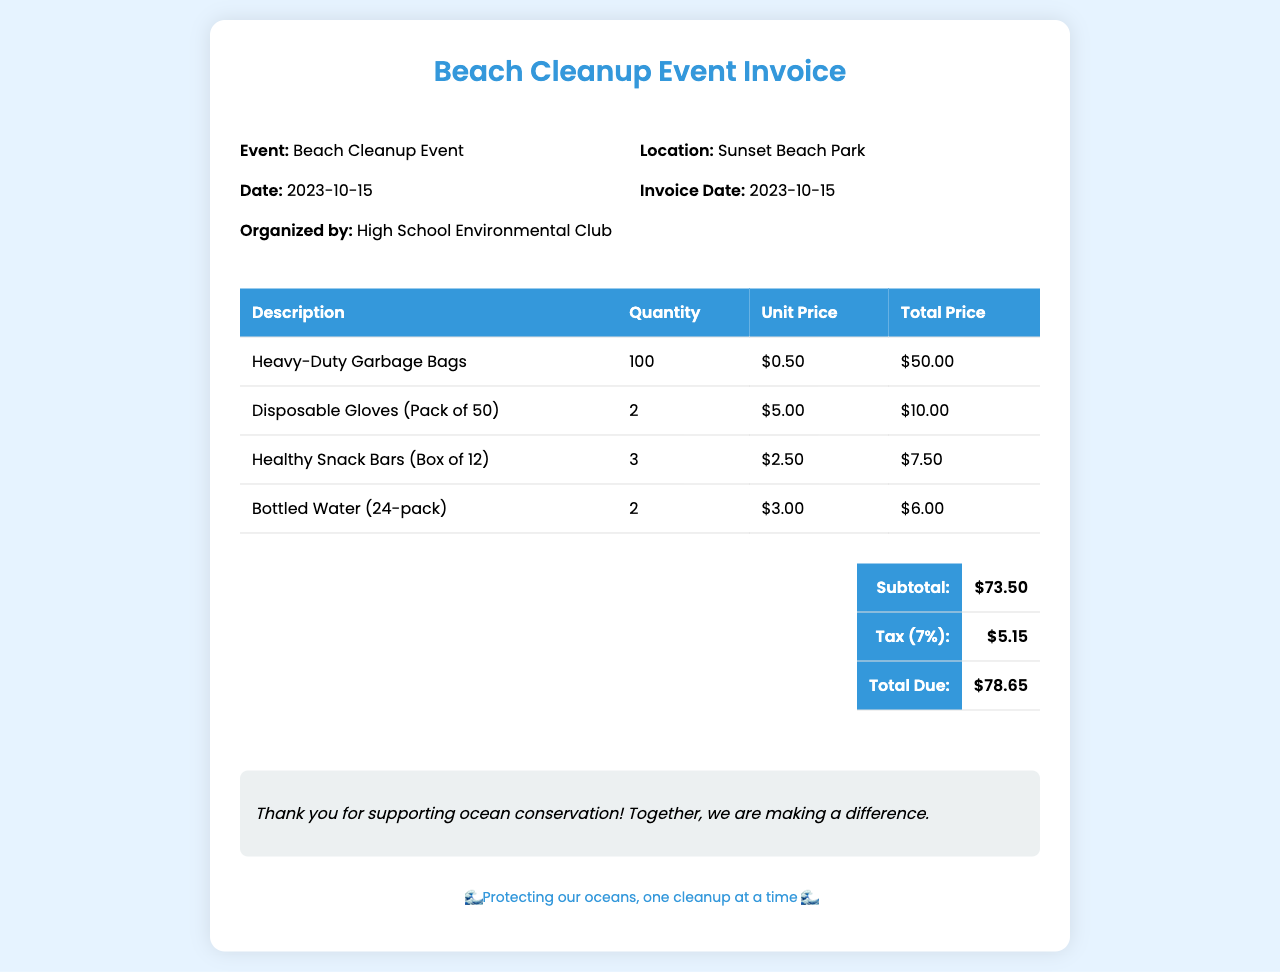What is the event name? The event name is listed at the top of the invoice, which states "Beach Cleanup Event."
Answer: Beach Cleanup Event What is the date of the event? The date of the event is mentioned in the details section of the invoice, showing "2023-10-15."
Answer: 2023-10-15 Where is the event location? The location of the event is provided in the details section, specifically indicating "Sunset Beach Park."
Answer: Sunset Beach Park What is the total due amount? The total due is calculated in the total section, which sums the subtotal and tax, displayed as "$78.65."
Answer: $78.65 How many heavy-duty garbage bags were purchased? The quantity of heavy-duty garbage bags is found in the table under "Quantity," specifically stating "100."
Answer: 100 What is the subtotal before tax? The subtotal is provided in the total section before the tax is added, indicated as "$73.50."
Answer: $73.50 What percentage is the tax applied? The tax rate is mentioned as "7%" in the total section of the invoice.
Answer: 7% How many packs of disposable gloves were ordered? The quantity of disposable gloves ordered can be found in the itemized table, which shows "2."
Answer: 2 What is the purpose of the invoice notes? The notes at the bottom express gratitude for supporting ocean conservation, indicating the purpose is to encourage environmental efforts.
Answer: Thank you for supporting ocean conservation! 